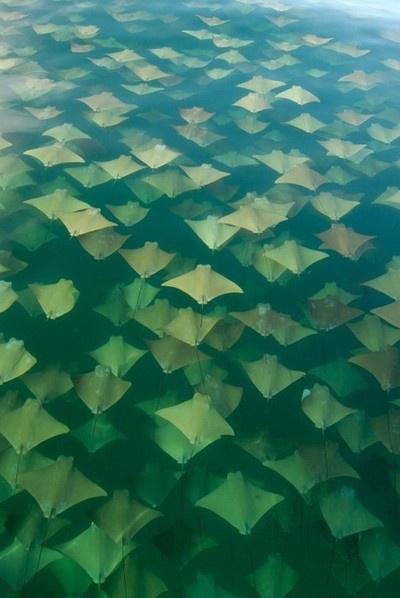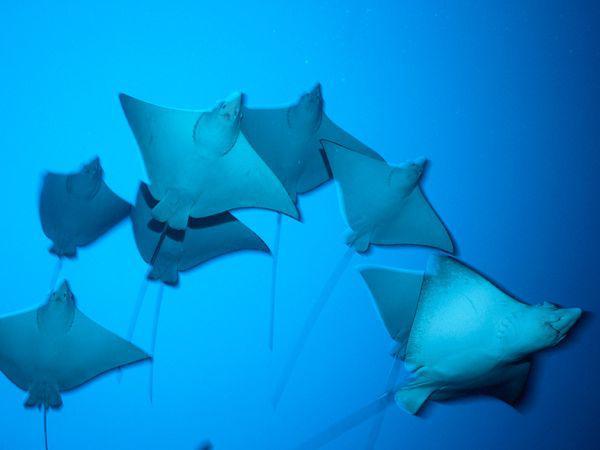The first image is the image on the left, the second image is the image on the right. Given the left and right images, does the statement "At least one image contains no more than three stingray." hold true? Answer yes or no. No. The first image is the image on the left, the second image is the image on the right. Considering the images on both sides, is "There are at most 4 sting rays in one of the images." valid? Answer yes or no. No. 